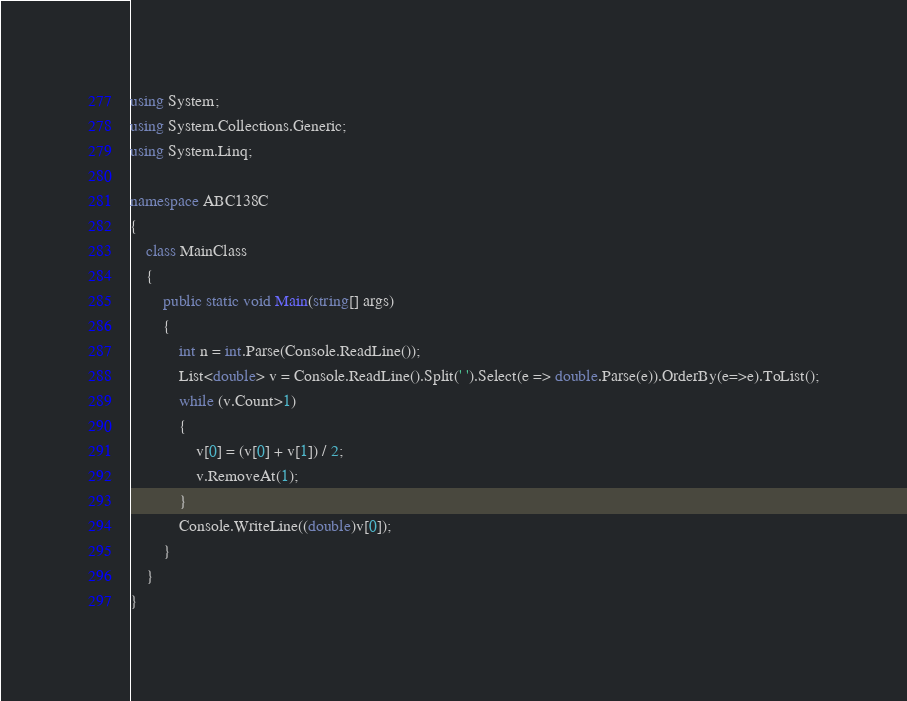<code> <loc_0><loc_0><loc_500><loc_500><_C#_>using System;
using System.Collections.Generic;
using System.Linq;

namespace ABC138C
{
    class MainClass
    {
        public static void Main(string[] args)
        {
            int n = int.Parse(Console.ReadLine());
            List<double> v = Console.ReadLine().Split(' ').Select(e => double.Parse(e)).OrderBy(e=>e).ToList();
            while (v.Count>1)
            {
                v[0] = (v[0] + v[1]) / 2;
                v.RemoveAt(1);
            }
            Console.WriteLine((double)v[0]);
        }
    }
}
</code> 